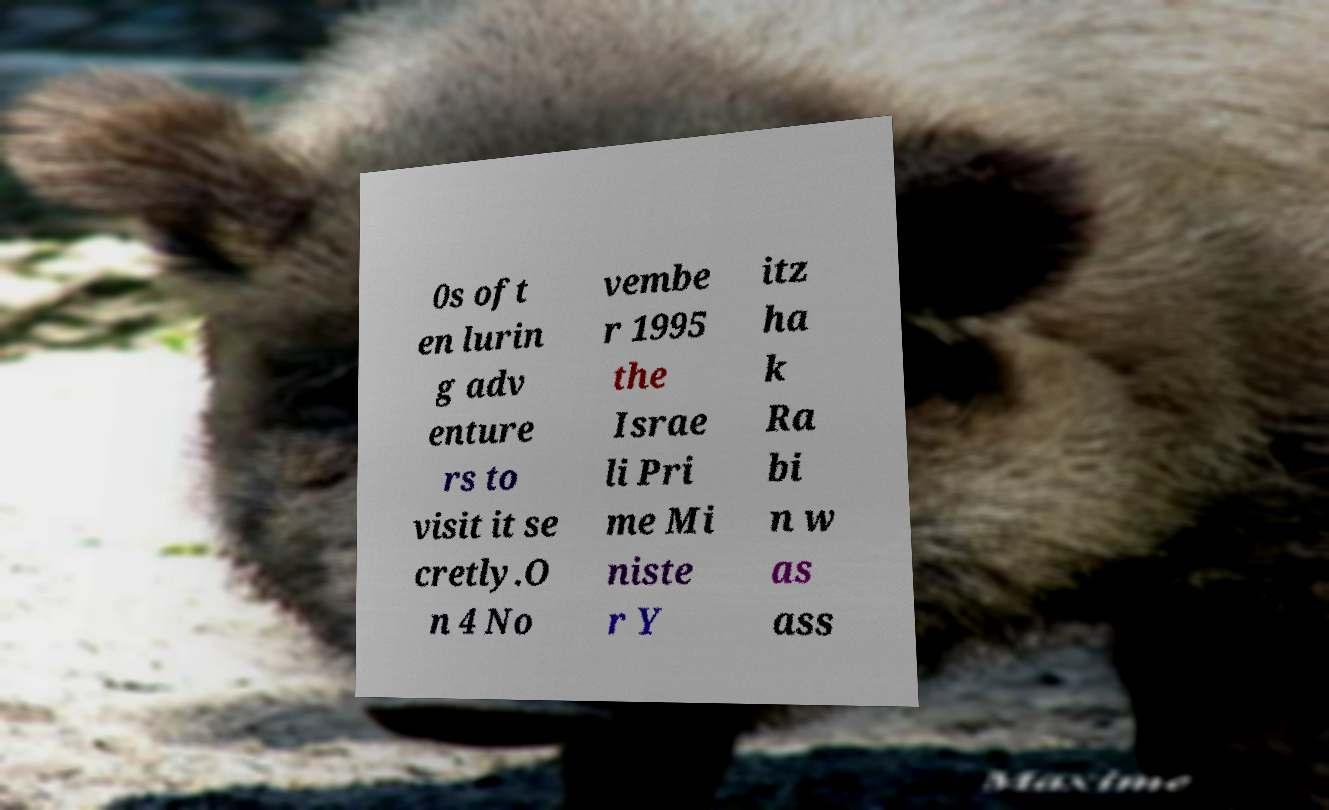Please read and relay the text visible in this image. What does it say? 0s oft en lurin g adv enture rs to visit it se cretly.O n 4 No vembe r 1995 the Israe li Pri me Mi niste r Y itz ha k Ra bi n w as ass 